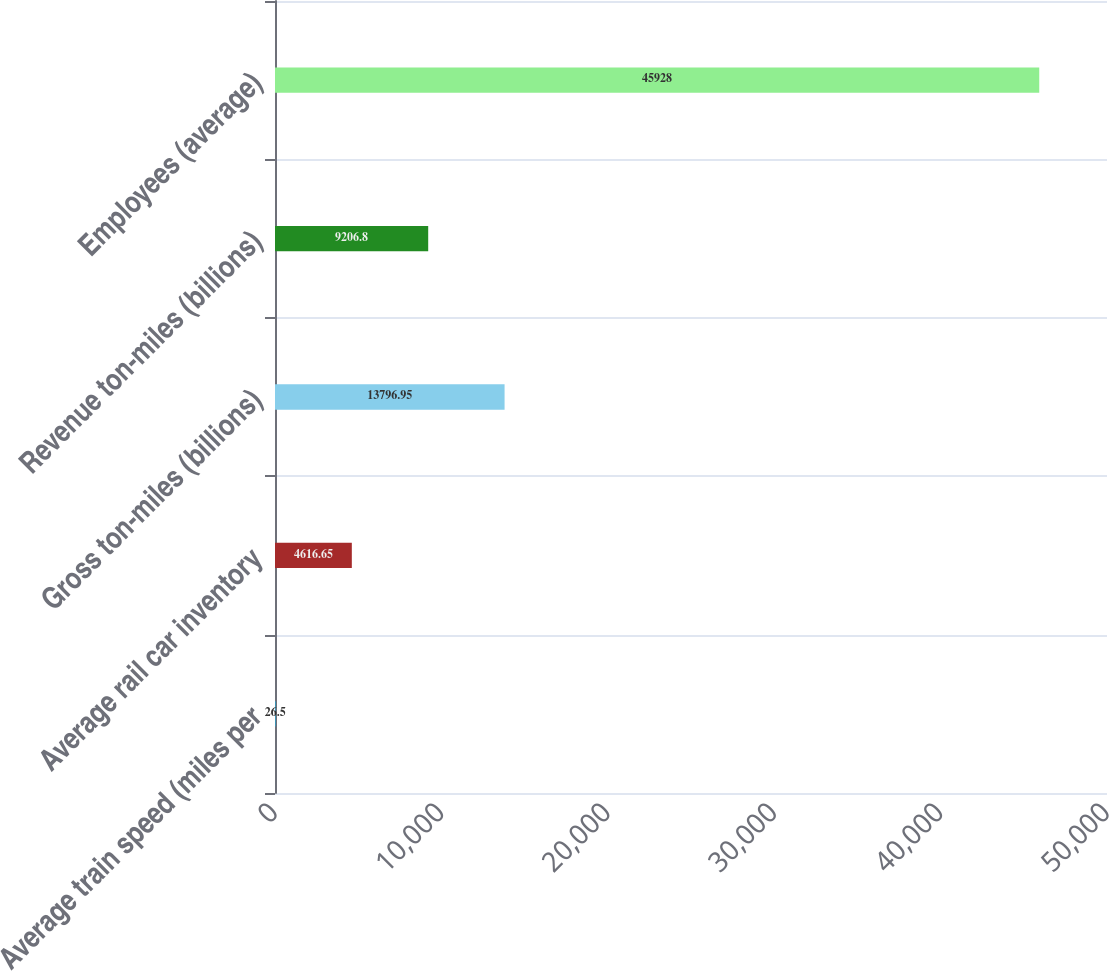<chart> <loc_0><loc_0><loc_500><loc_500><bar_chart><fcel>Average train speed (miles per<fcel>Average rail car inventory<fcel>Gross ton-miles (billions)<fcel>Revenue ton-miles (billions)<fcel>Employees (average)<nl><fcel>26.5<fcel>4616.65<fcel>13797<fcel>9206.8<fcel>45928<nl></chart> 